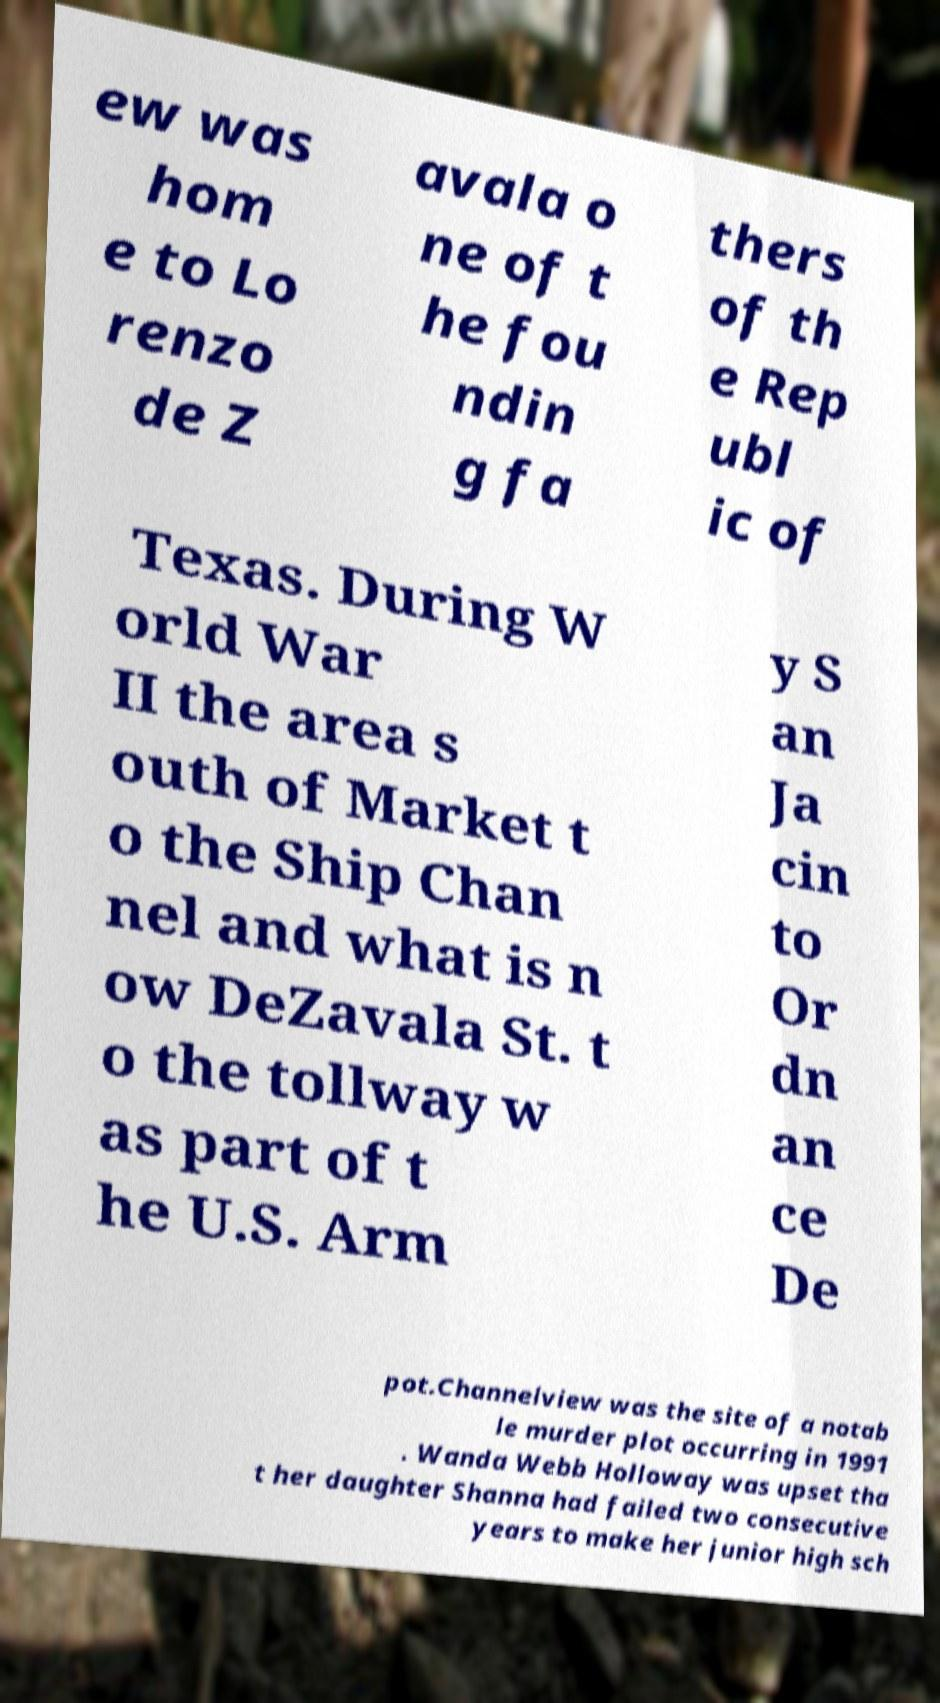Please identify and transcribe the text found in this image. ew was hom e to Lo renzo de Z avala o ne of t he fou ndin g fa thers of th e Rep ubl ic of Texas. During W orld War II the area s outh of Market t o the Ship Chan nel and what is n ow DeZavala St. t o the tollway w as part of t he U.S. Arm y S an Ja cin to Or dn an ce De pot.Channelview was the site of a notab le murder plot occurring in 1991 . Wanda Webb Holloway was upset tha t her daughter Shanna had failed two consecutive years to make her junior high sch 